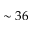Convert formula to latex. <formula><loc_0><loc_0><loc_500><loc_500>\sim 3 6</formula> 